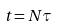<formula> <loc_0><loc_0><loc_500><loc_500>t = N \tau</formula> 